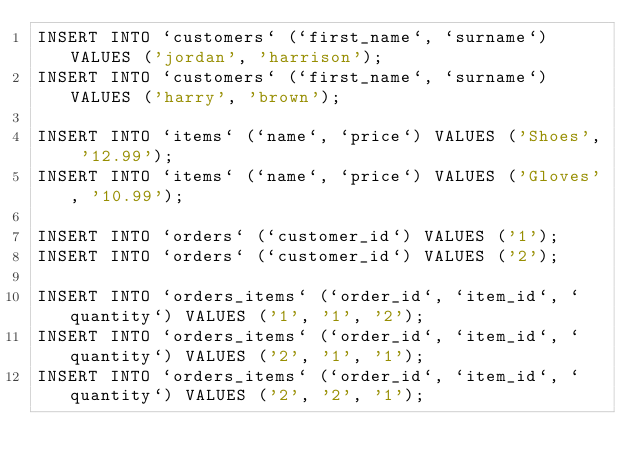<code> <loc_0><loc_0><loc_500><loc_500><_SQL_>INSERT INTO `customers` (`first_name`, `surname`) VALUES ('jordan', 'harrison');
INSERT INTO `customers` (`first_name`, `surname`) VALUES ('harry', 'brown');

INSERT INTO `items` (`name`, `price`) VALUES ('Shoes', '12.99');
INSERT INTO `items` (`name`, `price`) VALUES ('Gloves', '10.99');

INSERT INTO `orders` (`customer_id`) VALUES ('1');
INSERT INTO `orders` (`customer_id`) VALUES ('2');

INSERT INTO `orders_items` (`order_id`, `item_id`, `quantity`) VALUES ('1', '1', '2');
INSERT INTO `orders_items` (`order_id`, `item_id`, `quantity`) VALUES ('2', '1', '1');
INSERT INTO `orders_items` (`order_id`, `item_id`, `quantity`) VALUES ('2', '2', '1');</code> 